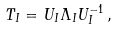<formula> <loc_0><loc_0><loc_500><loc_500>T _ { I } = U _ { I } \Lambda _ { I } U _ { I } ^ { - 1 } \, ,</formula> 